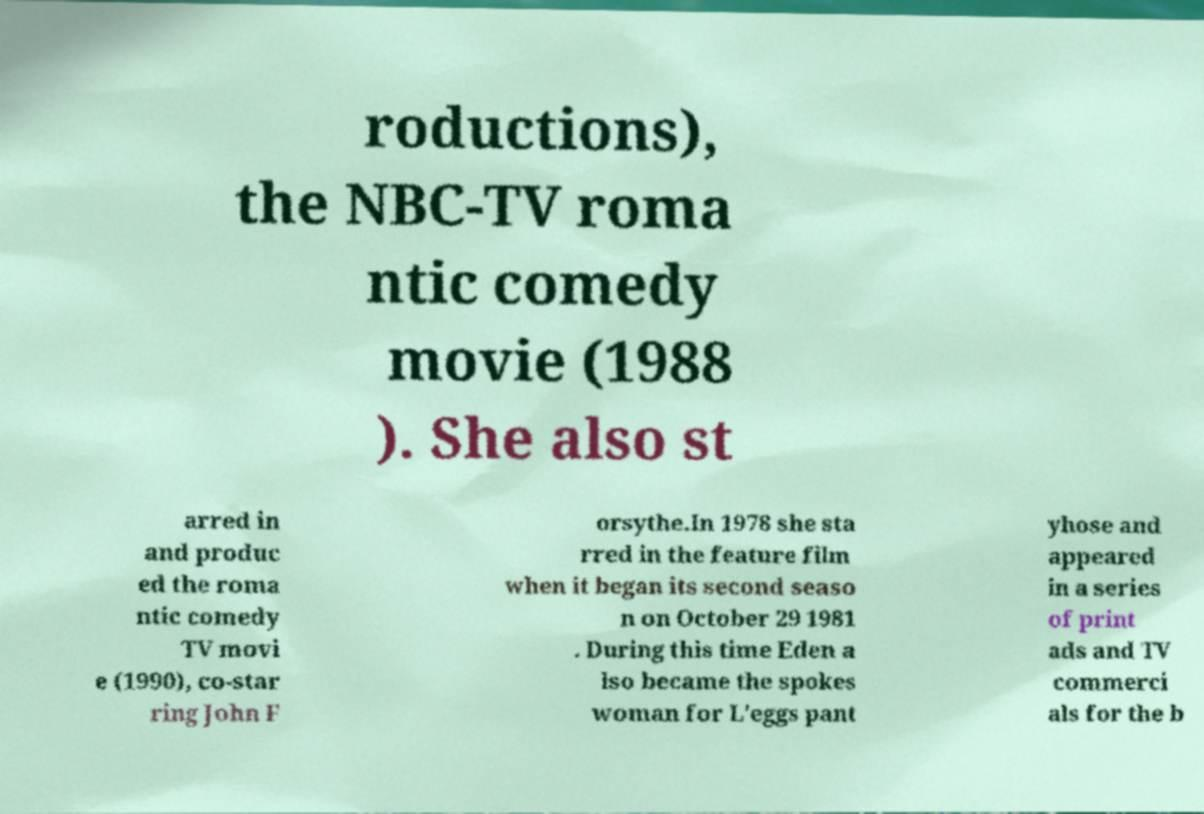For documentation purposes, I need the text within this image transcribed. Could you provide that? roductions), the NBC-TV roma ntic comedy movie (1988 ). She also st arred in and produc ed the roma ntic comedy TV movi e (1990), co-star ring John F orsythe.In 1978 she sta rred in the feature film when it began its second seaso n on October 29 1981 . During this time Eden a lso became the spokes woman for L'eggs pant yhose and appeared in a series of print ads and TV commerci als for the b 